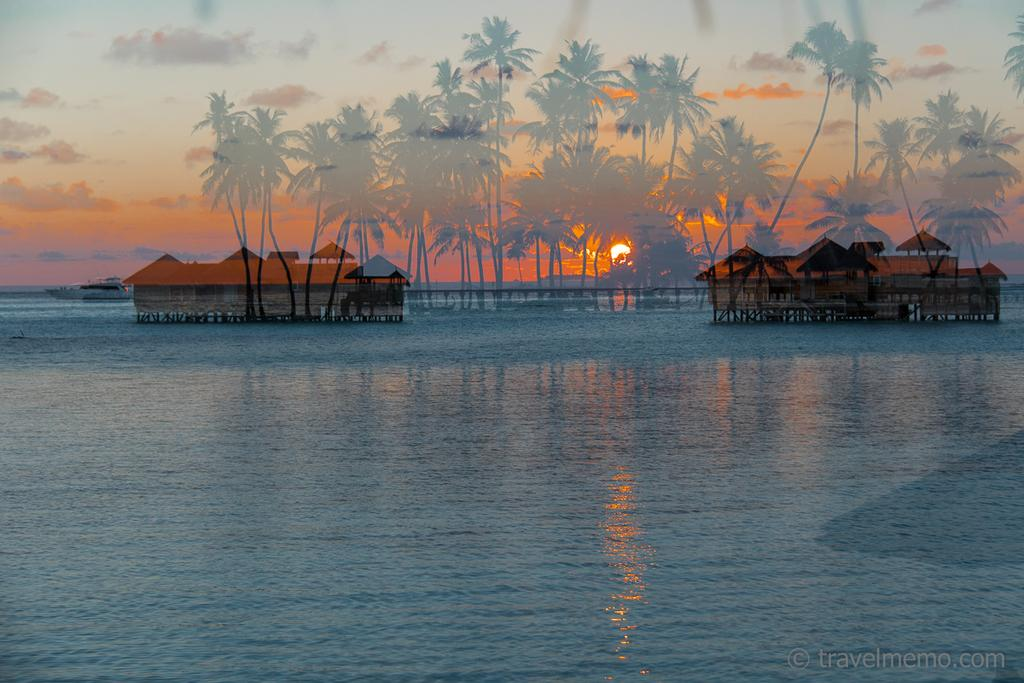What is the primary element in the image? There is water in the image. What structures can be seen in the image? There are houses in the image. What type of vegetation is present in the image? There are trees in the image. What can be seen in the background of the image? There is a boat and the sky visible in the background of the image. What is the condition of the sky in the image? Clouds are present in the sky. What type of floor can be seen in the image? There is no floor visible in the image, as it primarily features water. Can you tell me the judge's name from the image? There is no judge present in the image. 